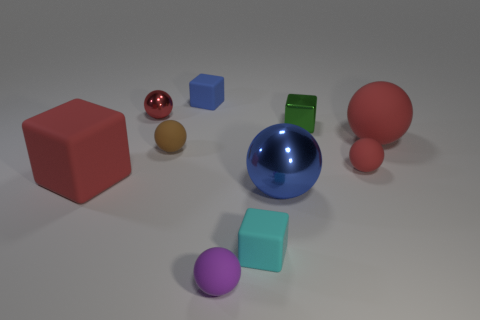How would you describe the arrangement of the objects, and what might it say about the theme or concept being conveyed? The objects are arranged haphazardly across a neutral surface, suggesting a randomness that may imply a theme of diversity or individuality. Each object's unique color, shape, and texture stand out, celebrating variety and contrast. 